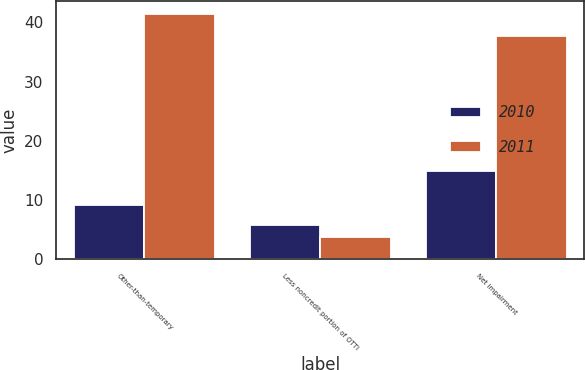Convert chart. <chart><loc_0><loc_0><loc_500><loc_500><stacked_bar_chart><ecel><fcel>Other-than-temporary<fcel>Less noncredit portion of OTTI<fcel>Net impairment<nl><fcel>2010<fcel>9.2<fcel>5.7<fcel>14.9<nl><fcel>2011<fcel>41.5<fcel>3.8<fcel>37.7<nl></chart> 